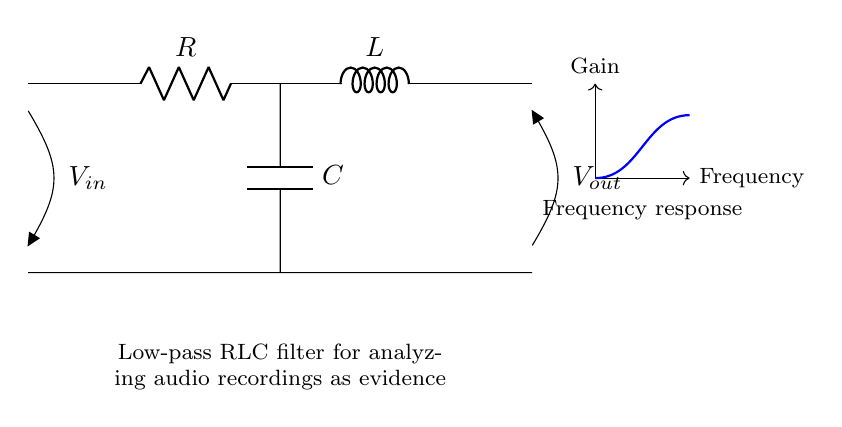What are the components present in this circuit? The components in the circuit are a resistor, an inductor, and a capacitor. These are the three primary components used in creating a low-pass RLC filter.
Answer: resistor, inductor, capacitor What is the purpose of this circuit? This circuit is designed as a low-pass RLC filter which allows low-frequency signals to pass through while attenuating high-frequency signals. Its purpose is particularly relevant in analyzing audio recordings as evidence.
Answer: Low-pass filter What connections are made to the capacitor? The capacitor is connected in parallel with the output voltage, effectively filtering the output signal based on frequency. One terminal is connected to the signal path and the other to the ground.
Answer: Parallel with output What is the type of filter represented by this circuit? This circuit represents a low-pass filter, as it is designed to pass signals below a certain cutoff frequency while attenuating signals above that frequency.
Answer: Low-pass filter What is the effect of increasing the inductor value on the filter? Increasing the inductor value will increase the cutoff frequency of the low-pass filter, allowing it to react more slowly to changes in input signal frequencies.
Answer: Increases cutoff frequency What is the input voltage in this circuit? The input voltage is indicated as V_in in the diagram, which represents the voltage applied to the circuit from the input signal source.
Answer: V_in How does the frequency response curve behave for this low-pass filter? The frequency response curve of a low-pass filter shows that the gain decreases as frequency increases, indicating that higher frequency signals are progressively attenuated.
Answer: Decreases with frequency 